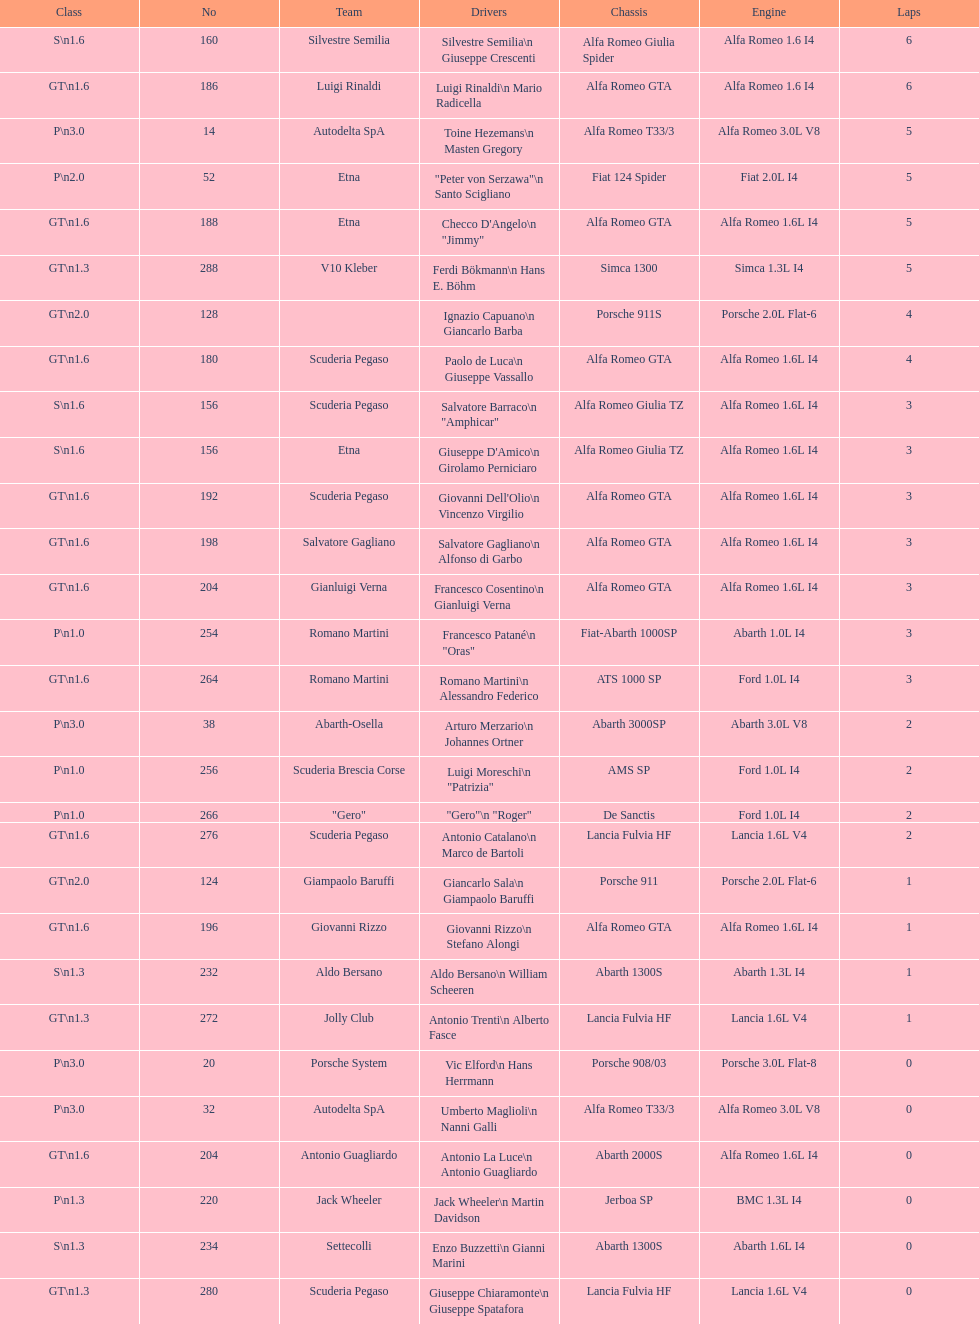His nickname is "jimmy," but what is his full name? Checco D'Angelo. 